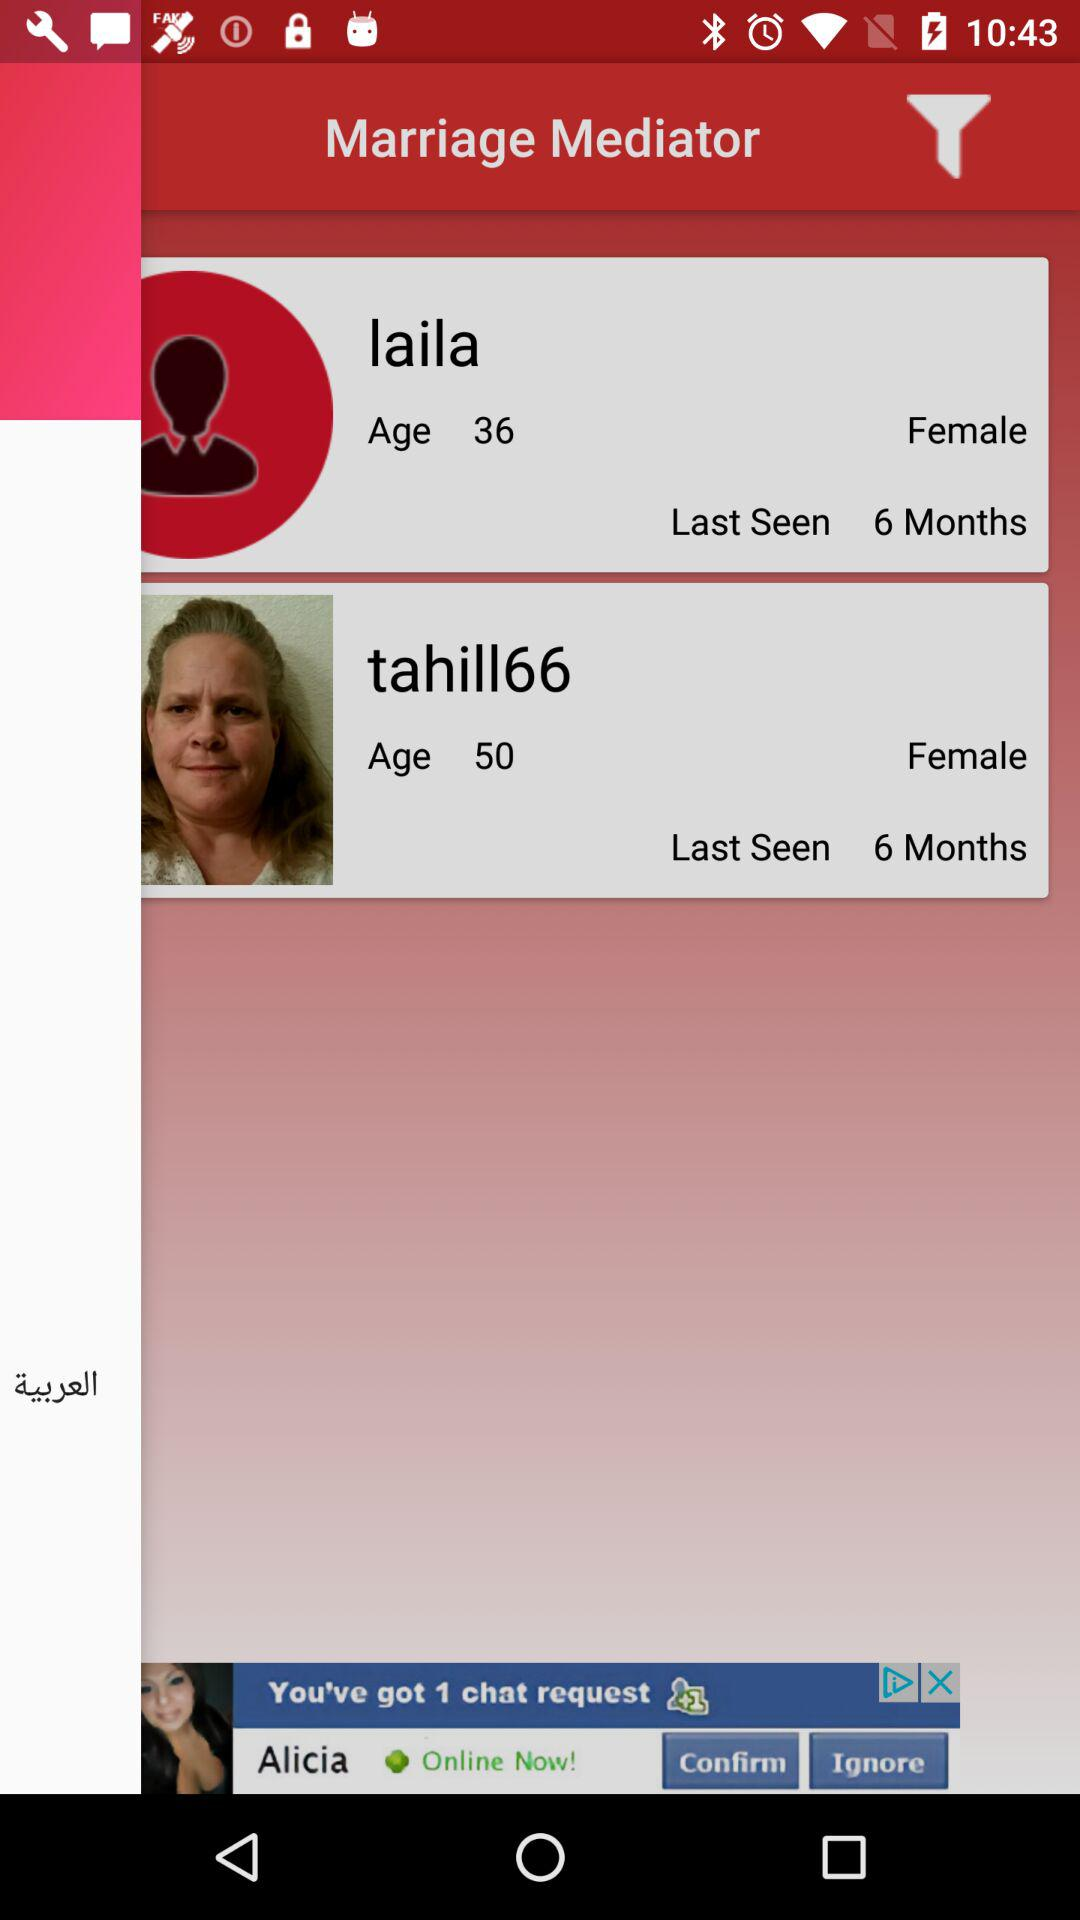What is the last seen of laila? The last seen of Laila is 6 months ago. 